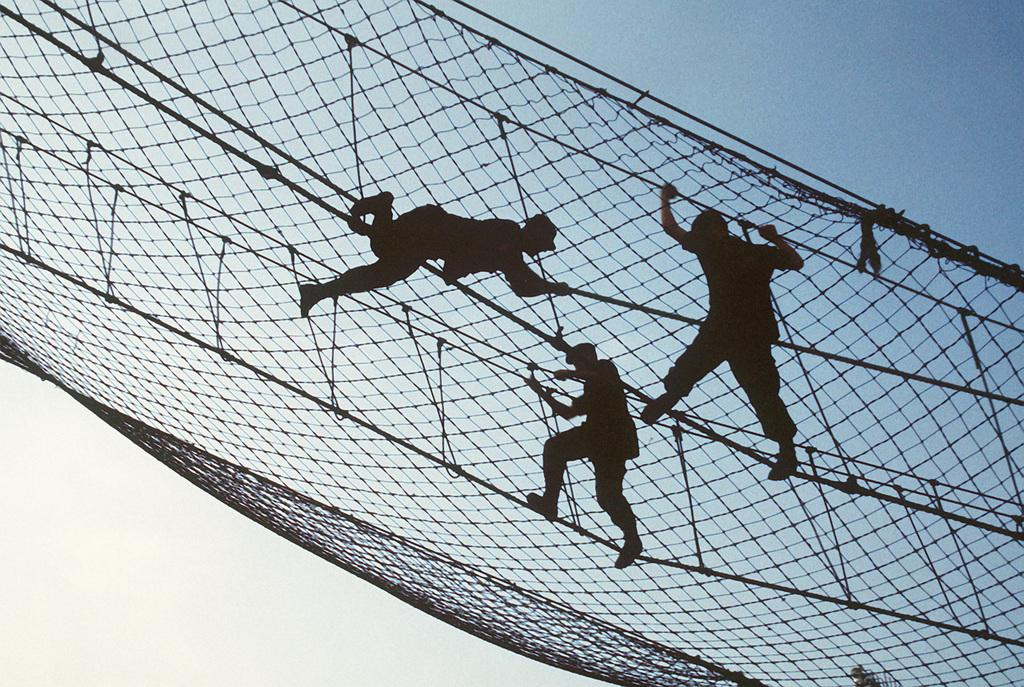What is happening in the image involving a group of people? The people in the image are climbing a net. What other objects are visible in the image besides the net? There are ropes visible in the image, as well as other unspecified objects. What can be seen in the background of the image? The sky is visible in the background of the image. What type of agreement can be seen being signed by the people in the image? There is no agreement being signed in the image; the people are climbing a net. What kind of branch is being used by the people to climb the net in the image? There are no branches visible in the image; the people are using a net and ropes to climb. 